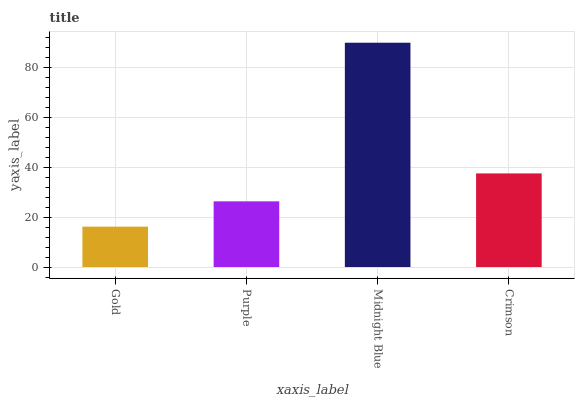Is Gold the minimum?
Answer yes or no. Yes. Is Midnight Blue the maximum?
Answer yes or no. Yes. Is Purple the minimum?
Answer yes or no. No. Is Purple the maximum?
Answer yes or no. No. Is Purple greater than Gold?
Answer yes or no. Yes. Is Gold less than Purple?
Answer yes or no. Yes. Is Gold greater than Purple?
Answer yes or no. No. Is Purple less than Gold?
Answer yes or no. No. Is Crimson the high median?
Answer yes or no. Yes. Is Purple the low median?
Answer yes or no. Yes. Is Purple the high median?
Answer yes or no. No. Is Crimson the low median?
Answer yes or no. No. 